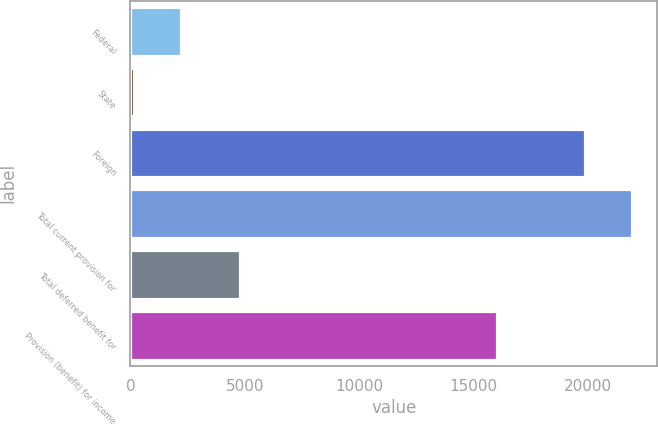Convert chart to OTSL. <chart><loc_0><loc_0><loc_500><loc_500><bar_chart><fcel>Federal<fcel>State<fcel>Foreign<fcel>Total current provision for<fcel>Total deferred benefit for<fcel>Provision (benefit) for income<nl><fcel>2210.1<fcel>143<fcel>19870<fcel>21937.1<fcel>4775<fcel>16039<nl></chart> 